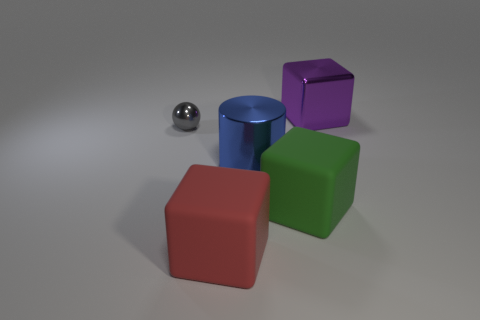Is there any other thing that is the same size as the gray shiny ball?
Keep it short and to the point. No. There is a large purple thing that is made of the same material as the small thing; what is its shape?
Your answer should be compact. Cube. Is there anything else of the same color as the shiny block?
Keep it short and to the point. No. What is the big green cube behind the rubber cube that is to the left of the green rubber thing made of?
Ensure brevity in your answer.  Rubber. Is there another large thing that has the same shape as the green rubber thing?
Your answer should be compact. Yes. How many other objects are there of the same shape as the tiny shiny object?
Offer a very short reply. 0. There is a object that is both to the right of the shiny cylinder and in front of the big purple shiny block; what is its shape?
Your answer should be very brief. Cube. There is a object that is on the left side of the red rubber thing; how big is it?
Your answer should be compact. Small. Do the red matte block and the ball have the same size?
Provide a short and direct response. No. Is the number of small shiny things in front of the large blue thing less than the number of green rubber cubes that are in front of the large purple shiny object?
Your answer should be very brief. Yes. 